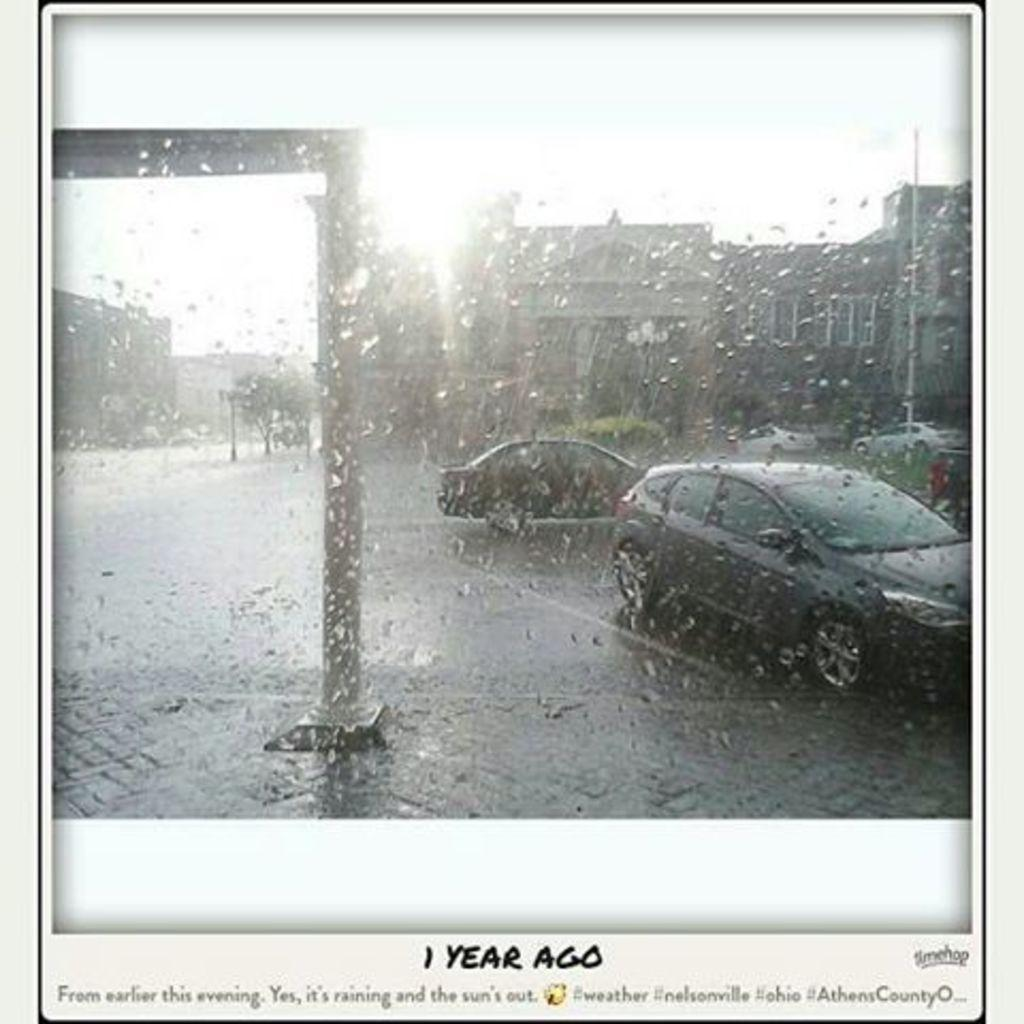What is the main subject in the center of the image? There is a poster in the center of the image. What type of images are featured on the poster? The poster contains images of buildings and cars. On which side of the poster are the cars located? The cars are on the right side of the poster. How many trees can be seen in the image? There are no trees visible in the image; it features a poster with images of buildings and cars. What type of vessel is being used by the basketball player in the image? There is no vessel or basketball player present in the image. 